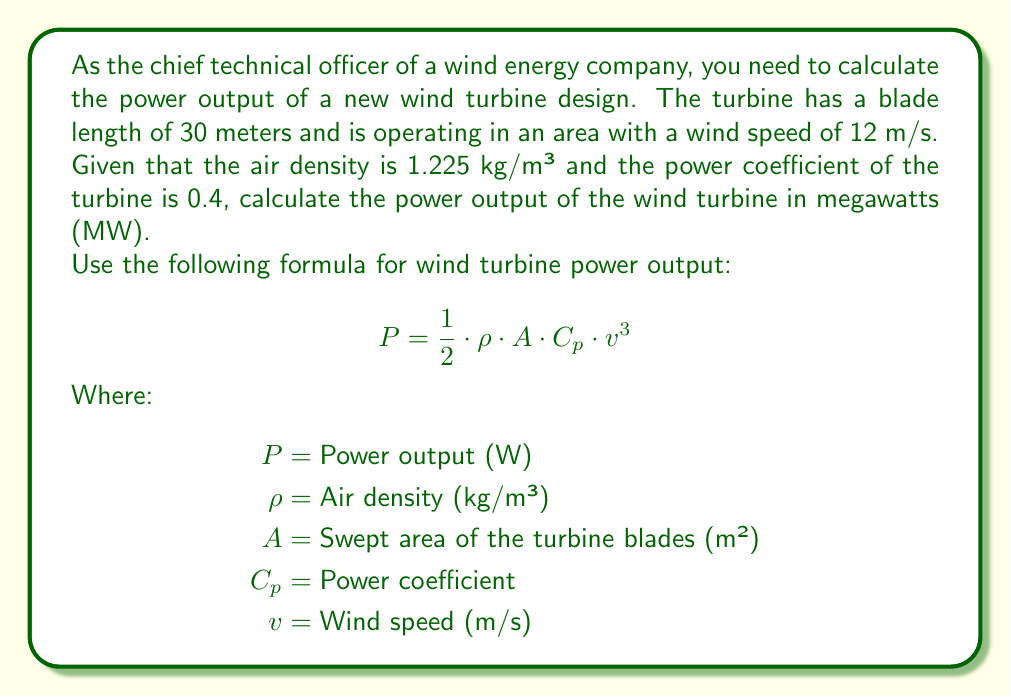Give your solution to this math problem. To solve this problem, we'll follow these steps:

1. Calculate the swept area of the turbine blades:
   The swept area is a circle with a radius equal to the blade length.
   $$ A = \pi r^2 = \pi \cdot 30^2 = 2827.43 \text{ m}^2 $$

2. Plug all the given values into the power output formula:
   $$ P = \frac{1}{2} \cdot 1.225 \text{ kg/m}^3 \cdot 2827.43 \text{ m}^2 \cdot 0.4 \cdot (12 \text{ m/s})^3 $$

3. Simplify and calculate:
   $$ P = 0.5 \cdot 1.225 \cdot 2827.43 \cdot 0.4 \cdot 1728 $$
   $$ P = 1,196,925.48 \text{ W} $$

4. Convert watts to megawatts:
   $$ P = 1,196,925.48 \text{ W} \cdot \frac{1 \text{ MW}}{1,000,000 \text{ W}} = 1.197 \text{ MW} $$

Therefore, the power output of the wind turbine is approximately 1.197 MW.
Answer: 1.197 MW 